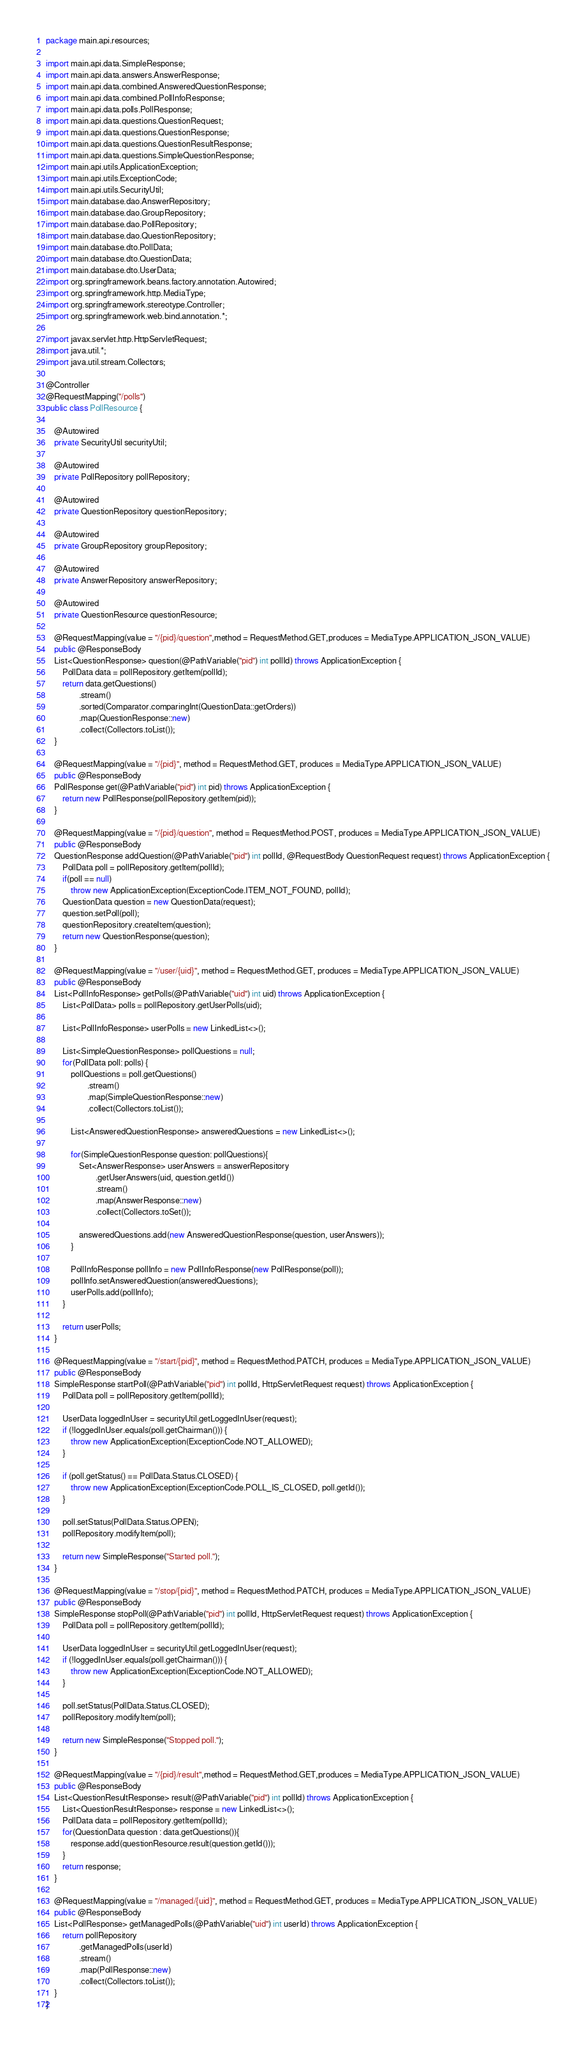<code> <loc_0><loc_0><loc_500><loc_500><_Java_>package main.api.resources;

import main.api.data.SimpleResponse;
import main.api.data.answers.AnswerResponse;
import main.api.data.combined.AnsweredQuestionResponse;
import main.api.data.combined.PollInfoResponse;
import main.api.data.polls.PollResponse;
import main.api.data.questions.QuestionRequest;
import main.api.data.questions.QuestionResponse;
import main.api.data.questions.QuestionResultResponse;
import main.api.data.questions.SimpleQuestionResponse;
import main.api.utils.ApplicationException;
import main.api.utils.ExceptionCode;
import main.api.utils.SecurityUtil;
import main.database.dao.AnswerRepository;
import main.database.dao.GroupRepository;
import main.database.dao.PollRepository;
import main.database.dao.QuestionRepository;
import main.database.dto.PollData;
import main.database.dto.QuestionData;
import main.database.dto.UserData;
import org.springframework.beans.factory.annotation.Autowired;
import org.springframework.http.MediaType;
import org.springframework.stereotype.Controller;
import org.springframework.web.bind.annotation.*;

import javax.servlet.http.HttpServletRequest;
import java.util.*;
import java.util.stream.Collectors;

@Controller
@RequestMapping("/polls")
public class PollResource {

    @Autowired
    private SecurityUtil securityUtil;

    @Autowired
    private PollRepository pollRepository;

    @Autowired
    private QuestionRepository questionRepository;

    @Autowired
    private GroupRepository groupRepository;

    @Autowired
    private AnswerRepository answerRepository;

    @Autowired
    private QuestionResource questionResource;

    @RequestMapping(value = "/{pid}/question",method = RequestMethod.GET,produces = MediaType.APPLICATION_JSON_VALUE)
    public @ResponseBody
    List<QuestionResponse> question(@PathVariable("pid") int pollId) throws ApplicationException {
        PollData data = pollRepository.getItem(pollId);
        return data.getQuestions()
                .stream()
                .sorted(Comparator.comparingInt(QuestionData::getOrders))
                .map(QuestionResponse::new)
                .collect(Collectors.toList());
    }

    @RequestMapping(value = "/{pid}", method = RequestMethod.GET, produces = MediaType.APPLICATION_JSON_VALUE)
    public @ResponseBody
    PollResponse get(@PathVariable("pid") int pid) throws ApplicationException {
        return new PollResponse(pollRepository.getItem(pid));
    }

    @RequestMapping(value = "/{pid}/question", method = RequestMethod.POST, produces = MediaType.APPLICATION_JSON_VALUE)
    public @ResponseBody
    QuestionResponse addQuestion(@PathVariable("pid") int pollId, @RequestBody QuestionRequest request) throws ApplicationException {
        PollData poll = pollRepository.getItem(pollId);
        if(poll == null)
            throw new ApplicationException(ExceptionCode.ITEM_NOT_FOUND, pollId);
        QuestionData question = new QuestionData(request);
        question.setPoll(poll);
        questionRepository.createItem(question);
        return new QuestionResponse(question);
    }

    @RequestMapping(value = "/user/{uid}", method = RequestMethod.GET, produces = MediaType.APPLICATION_JSON_VALUE)
    public @ResponseBody
    List<PollInfoResponse> getPolls(@PathVariable("uid") int uid) throws ApplicationException {
        List<PollData> polls = pollRepository.getUserPolls(uid);

        List<PollInfoResponse> userPolls = new LinkedList<>();

        List<SimpleQuestionResponse> pollQuestions = null;
        for(PollData poll: polls) {
            pollQuestions = poll.getQuestions()
                    .stream()
                    .map(SimpleQuestionResponse::new)
                    .collect(Collectors.toList());

            List<AnsweredQuestionResponse> answeredQuestions = new LinkedList<>();

            for(SimpleQuestionResponse question: pollQuestions){
                Set<AnswerResponse> userAnswers = answerRepository
                        .getUserAnswers(uid, question.getId())
                        .stream()
                        .map(AnswerResponse::new)
                        .collect(Collectors.toSet());

                answeredQuestions.add(new AnsweredQuestionResponse(question, userAnswers));
            }

            PollInfoResponse pollInfo = new PollInfoResponse(new PollResponse(poll));
            pollInfo.setAnsweredQuestion(answeredQuestions);
            userPolls.add(pollInfo);
        }

        return userPolls;
    }

    @RequestMapping(value = "/start/{pid}", method = RequestMethod.PATCH, produces = MediaType.APPLICATION_JSON_VALUE)
    public @ResponseBody
    SimpleResponse startPoll(@PathVariable("pid") int pollId, HttpServletRequest request) throws ApplicationException {
        PollData poll = pollRepository.getItem(pollId);

        UserData loggedInUser = securityUtil.getLoggedInUser(request);
        if (!loggedInUser.equals(poll.getChairman())) {
            throw new ApplicationException(ExceptionCode.NOT_ALLOWED);
        }

        if (poll.getStatus() == PollData.Status.CLOSED) {
            throw new ApplicationException(ExceptionCode.POLL_IS_CLOSED, poll.getId());
        }

        poll.setStatus(PollData.Status.OPEN);
        pollRepository.modifyItem(poll);

        return new SimpleResponse("Started poll.");
    }

    @RequestMapping(value = "/stop/{pid}", method = RequestMethod.PATCH, produces = MediaType.APPLICATION_JSON_VALUE)
    public @ResponseBody
    SimpleResponse stopPoll(@PathVariable("pid") int pollId, HttpServletRequest request) throws ApplicationException {
        PollData poll = pollRepository.getItem(pollId);

        UserData loggedInUser = securityUtil.getLoggedInUser(request);
        if (!loggedInUser.equals(poll.getChairman())) {
            throw new ApplicationException(ExceptionCode.NOT_ALLOWED);
        }

        poll.setStatus(PollData.Status.CLOSED);
        pollRepository.modifyItem(poll);

        return new SimpleResponse("Stopped poll.");
    }

    @RequestMapping(value = "/{pid}/result",method = RequestMethod.GET,produces = MediaType.APPLICATION_JSON_VALUE)
    public @ResponseBody
    List<QuestionResultResponse> result(@PathVariable("pid") int pollId) throws ApplicationException {
        List<QuestionResultResponse> response = new LinkedList<>();
        PollData data = pollRepository.getItem(pollId);
        for(QuestionData question : data.getQuestions()){
            response.add(questionResource.result(question.getId()));
        }
        return response;
    }

    @RequestMapping(value = "/managed/{uid}", method = RequestMethod.GET, produces = MediaType.APPLICATION_JSON_VALUE)
    public @ResponseBody
    List<PollResponse> getManagedPolls(@PathVariable("uid") int userId) throws ApplicationException {
        return pollRepository
                .getManagedPolls(userId)
                .stream()
                .map(PollResponse::new)
                .collect(Collectors.toList());
    }
}
</code> 